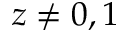<formula> <loc_0><loc_0><loc_500><loc_500>z \neq 0 , 1</formula> 